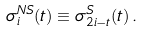Convert formula to latex. <formula><loc_0><loc_0><loc_500><loc_500>\sigma _ { i } ^ { N S } ( t ) \equiv \sigma _ { 2 i - t } ^ { S } ( t ) \, .</formula> 